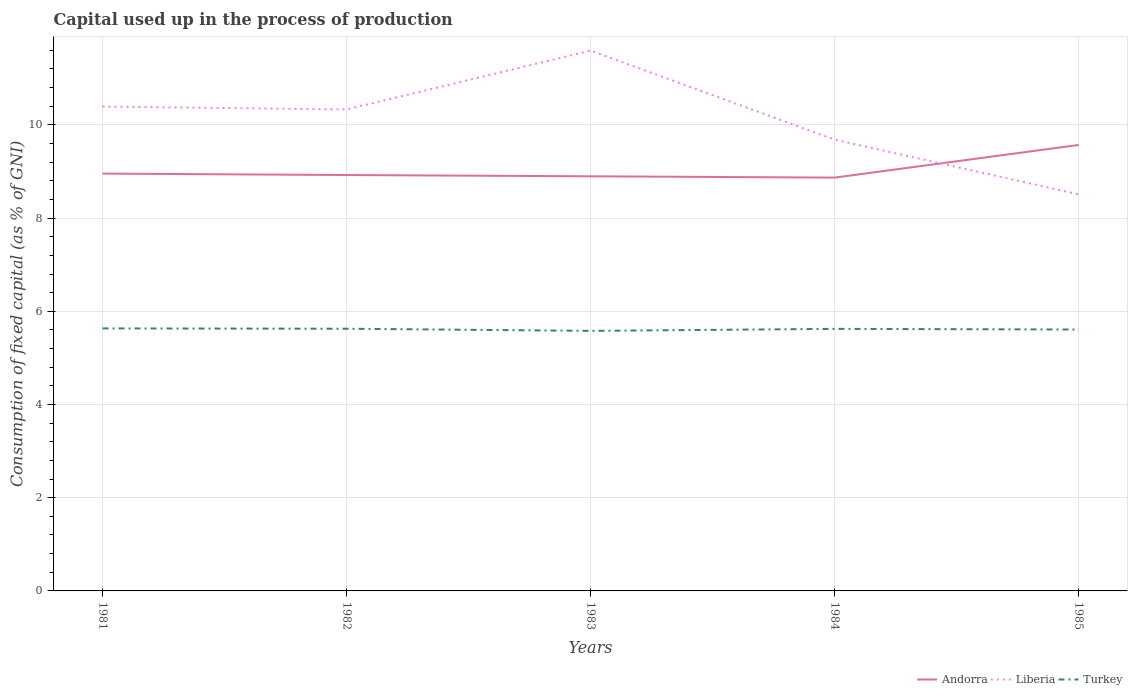How many different coloured lines are there?
Your response must be concise. 3. Does the line corresponding to Liberia intersect with the line corresponding to Turkey?
Make the answer very short. No. Across all years, what is the maximum capital used up in the process of production in Turkey?
Your answer should be compact. 5.58. In which year was the capital used up in the process of production in Andorra maximum?
Give a very brief answer. 1984. What is the total capital used up in the process of production in Turkey in the graph?
Your answer should be compact. 0. What is the difference between the highest and the second highest capital used up in the process of production in Andorra?
Your answer should be compact. 0.7. What is the difference between the highest and the lowest capital used up in the process of production in Liberia?
Provide a succinct answer. 3. Are the values on the major ticks of Y-axis written in scientific E-notation?
Give a very brief answer. No. How are the legend labels stacked?
Offer a very short reply. Horizontal. What is the title of the graph?
Keep it short and to the point. Capital used up in the process of production. What is the label or title of the Y-axis?
Your response must be concise. Consumption of fixed capital (as % of GNI). What is the Consumption of fixed capital (as % of GNI) of Andorra in 1981?
Offer a terse response. 8.95. What is the Consumption of fixed capital (as % of GNI) in Liberia in 1981?
Offer a very short reply. 10.39. What is the Consumption of fixed capital (as % of GNI) in Turkey in 1981?
Offer a very short reply. 5.63. What is the Consumption of fixed capital (as % of GNI) in Andorra in 1982?
Provide a short and direct response. 8.92. What is the Consumption of fixed capital (as % of GNI) of Liberia in 1982?
Your answer should be compact. 10.33. What is the Consumption of fixed capital (as % of GNI) of Turkey in 1982?
Provide a short and direct response. 5.63. What is the Consumption of fixed capital (as % of GNI) of Andorra in 1983?
Make the answer very short. 8.9. What is the Consumption of fixed capital (as % of GNI) of Liberia in 1983?
Provide a short and direct response. 11.59. What is the Consumption of fixed capital (as % of GNI) of Turkey in 1983?
Make the answer very short. 5.58. What is the Consumption of fixed capital (as % of GNI) in Andorra in 1984?
Keep it short and to the point. 8.87. What is the Consumption of fixed capital (as % of GNI) in Liberia in 1984?
Ensure brevity in your answer.  9.68. What is the Consumption of fixed capital (as % of GNI) of Turkey in 1984?
Provide a short and direct response. 5.62. What is the Consumption of fixed capital (as % of GNI) of Andorra in 1985?
Offer a very short reply. 9.57. What is the Consumption of fixed capital (as % of GNI) of Liberia in 1985?
Offer a very short reply. 8.51. What is the Consumption of fixed capital (as % of GNI) in Turkey in 1985?
Offer a terse response. 5.61. Across all years, what is the maximum Consumption of fixed capital (as % of GNI) of Andorra?
Offer a very short reply. 9.57. Across all years, what is the maximum Consumption of fixed capital (as % of GNI) of Liberia?
Provide a succinct answer. 11.59. Across all years, what is the maximum Consumption of fixed capital (as % of GNI) of Turkey?
Keep it short and to the point. 5.63. Across all years, what is the minimum Consumption of fixed capital (as % of GNI) in Andorra?
Offer a terse response. 8.87. Across all years, what is the minimum Consumption of fixed capital (as % of GNI) of Liberia?
Make the answer very short. 8.51. Across all years, what is the minimum Consumption of fixed capital (as % of GNI) in Turkey?
Your answer should be very brief. 5.58. What is the total Consumption of fixed capital (as % of GNI) of Andorra in the graph?
Give a very brief answer. 45.21. What is the total Consumption of fixed capital (as % of GNI) of Liberia in the graph?
Your answer should be very brief. 50.51. What is the total Consumption of fixed capital (as % of GNI) of Turkey in the graph?
Provide a succinct answer. 28.07. What is the difference between the Consumption of fixed capital (as % of GNI) in Andorra in 1981 and that in 1982?
Offer a very short reply. 0.03. What is the difference between the Consumption of fixed capital (as % of GNI) of Liberia in 1981 and that in 1982?
Keep it short and to the point. 0.06. What is the difference between the Consumption of fixed capital (as % of GNI) of Turkey in 1981 and that in 1982?
Keep it short and to the point. 0.01. What is the difference between the Consumption of fixed capital (as % of GNI) in Andorra in 1981 and that in 1983?
Your answer should be compact. 0.06. What is the difference between the Consumption of fixed capital (as % of GNI) in Liberia in 1981 and that in 1983?
Keep it short and to the point. -1.2. What is the difference between the Consumption of fixed capital (as % of GNI) of Turkey in 1981 and that in 1983?
Offer a very short reply. 0.05. What is the difference between the Consumption of fixed capital (as % of GNI) of Andorra in 1981 and that in 1984?
Provide a succinct answer. 0.09. What is the difference between the Consumption of fixed capital (as % of GNI) in Liberia in 1981 and that in 1984?
Ensure brevity in your answer.  0.71. What is the difference between the Consumption of fixed capital (as % of GNI) of Turkey in 1981 and that in 1984?
Offer a very short reply. 0.01. What is the difference between the Consumption of fixed capital (as % of GNI) of Andorra in 1981 and that in 1985?
Ensure brevity in your answer.  -0.61. What is the difference between the Consumption of fixed capital (as % of GNI) of Liberia in 1981 and that in 1985?
Provide a succinct answer. 1.88. What is the difference between the Consumption of fixed capital (as % of GNI) in Turkey in 1981 and that in 1985?
Your answer should be compact. 0.02. What is the difference between the Consumption of fixed capital (as % of GNI) of Andorra in 1982 and that in 1983?
Make the answer very short. 0.03. What is the difference between the Consumption of fixed capital (as % of GNI) in Liberia in 1982 and that in 1983?
Your answer should be very brief. -1.26. What is the difference between the Consumption of fixed capital (as % of GNI) in Turkey in 1982 and that in 1983?
Keep it short and to the point. 0.05. What is the difference between the Consumption of fixed capital (as % of GNI) of Andorra in 1982 and that in 1984?
Provide a succinct answer. 0.06. What is the difference between the Consumption of fixed capital (as % of GNI) in Liberia in 1982 and that in 1984?
Keep it short and to the point. 0.65. What is the difference between the Consumption of fixed capital (as % of GNI) in Turkey in 1982 and that in 1984?
Keep it short and to the point. 0. What is the difference between the Consumption of fixed capital (as % of GNI) of Andorra in 1982 and that in 1985?
Your answer should be compact. -0.65. What is the difference between the Consumption of fixed capital (as % of GNI) of Liberia in 1982 and that in 1985?
Provide a short and direct response. 1.82. What is the difference between the Consumption of fixed capital (as % of GNI) in Turkey in 1982 and that in 1985?
Provide a succinct answer. 0.02. What is the difference between the Consumption of fixed capital (as % of GNI) of Andorra in 1983 and that in 1984?
Provide a succinct answer. 0.03. What is the difference between the Consumption of fixed capital (as % of GNI) of Liberia in 1983 and that in 1984?
Make the answer very short. 1.91. What is the difference between the Consumption of fixed capital (as % of GNI) of Turkey in 1983 and that in 1984?
Keep it short and to the point. -0.04. What is the difference between the Consumption of fixed capital (as % of GNI) of Andorra in 1983 and that in 1985?
Offer a very short reply. -0.67. What is the difference between the Consumption of fixed capital (as % of GNI) in Liberia in 1983 and that in 1985?
Ensure brevity in your answer.  3.08. What is the difference between the Consumption of fixed capital (as % of GNI) of Turkey in 1983 and that in 1985?
Offer a very short reply. -0.03. What is the difference between the Consumption of fixed capital (as % of GNI) in Andorra in 1984 and that in 1985?
Provide a succinct answer. -0.7. What is the difference between the Consumption of fixed capital (as % of GNI) in Liberia in 1984 and that in 1985?
Your answer should be compact. 1.17. What is the difference between the Consumption of fixed capital (as % of GNI) in Turkey in 1984 and that in 1985?
Your answer should be compact. 0.01. What is the difference between the Consumption of fixed capital (as % of GNI) of Andorra in 1981 and the Consumption of fixed capital (as % of GNI) of Liberia in 1982?
Give a very brief answer. -1.38. What is the difference between the Consumption of fixed capital (as % of GNI) of Andorra in 1981 and the Consumption of fixed capital (as % of GNI) of Turkey in 1982?
Provide a succinct answer. 3.33. What is the difference between the Consumption of fixed capital (as % of GNI) in Liberia in 1981 and the Consumption of fixed capital (as % of GNI) in Turkey in 1982?
Make the answer very short. 4.77. What is the difference between the Consumption of fixed capital (as % of GNI) in Andorra in 1981 and the Consumption of fixed capital (as % of GNI) in Liberia in 1983?
Provide a succinct answer. -2.64. What is the difference between the Consumption of fixed capital (as % of GNI) in Andorra in 1981 and the Consumption of fixed capital (as % of GNI) in Turkey in 1983?
Give a very brief answer. 3.37. What is the difference between the Consumption of fixed capital (as % of GNI) of Liberia in 1981 and the Consumption of fixed capital (as % of GNI) of Turkey in 1983?
Provide a short and direct response. 4.81. What is the difference between the Consumption of fixed capital (as % of GNI) of Andorra in 1981 and the Consumption of fixed capital (as % of GNI) of Liberia in 1984?
Offer a very short reply. -0.73. What is the difference between the Consumption of fixed capital (as % of GNI) in Andorra in 1981 and the Consumption of fixed capital (as % of GNI) in Turkey in 1984?
Give a very brief answer. 3.33. What is the difference between the Consumption of fixed capital (as % of GNI) in Liberia in 1981 and the Consumption of fixed capital (as % of GNI) in Turkey in 1984?
Give a very brief answer. 4.77. What is the difference between the Consumption of fixed capital (as % of GNI) in Andorra in 1981 and the Consumption of fixed capital (as % of GNI) in Liberia in 1985?
Give a very brief answer. 0.45. What is the difference between the Consumption of fixed capital (as % of GNI) of Andorra in 1981 and the Consumption of fixed capital (as % of GNI) of Turkey in 1985?
Offer a terse response. 3.35. What is the difference between the Consumption of fixed capital (as % of GNI) in Liberia in 1981 and the Consumption of fixed capital (as % of GNI) in Turkey in 1985?
Make the answer very short. 4.78. What is the difference between the Consumption of fixed capital (as % of GNI) in Andorra in 1982 and the Consumption of fixed capital (as % of GNI) in Liberia in 1983?
Give a very brief answer. -2.67. What is the difference between the Consumption of fixed capital (as % of GNI) in Andorra in 1982 and the Consumption of fixed capital (as % of GNI) in Turkey in 1983?
Ensure brevity in your answer.  3.34. What is the difference between the Consumption of fixed capital (as % of GNI) in Liberia in 1982 and the Consumption of fixed capital (as % of GNI) in Turkey in 1983?
Give a very brief answer. 4.75. What is the difference between the Consumption of fixed capital (as % of GNI) of Andorra in 1982 and the Consumption of fixed capital (as % of GNI) of Liberia in 1984?
Give a very brief answer. -0.76. What is the difference between the Consumption of fixed capital (as % of GNI) of Andorra in 1982 and the Consumption of fixed capital (as % of GNI) of Turkey in 1984?
Make the answer very short. 3.3. What is the difference between the Consumption of fixed capital (as % of GNI) of Liberia in 1982 and the Consumption of fixed capital (as % of GNI) of Turkey in 1984?
Your answer should be very brief. 4.71. What is the difference between the Consumption of fixed capital (as % of GNI) of Andorra in 1982 and the Consumption of fixed capital (as % of GNI) of Liberia in 1985?
Give a very brief answer. 0.41. What is the difference between the Consumption of fixed capital (as % of GNI) in Andorra in 1982 and the Consumption of fixed capital (as % of GNI) in Turkey in 1985?
Your answer should be compact. 3.32. What is the difference between the Consumption of fixed capital (as % of GNI) of Liberia in 1982 and the Consumption of fixed capital (as % of GNI) of Turkey in 1985?
Your response must be concise. 4.72. What is the difference between the Consumption of fixed capital (as % of GNI) in Andorra in 1983 and the Consumption of fixed capital (as % of GNI) in Liberia in 1984?
Keep it short and to the point. -0.79. What is the difference between the Consumption of fixed capital (as % of GNI) of Andorra in 1983 and the Consumption of fixed capital (as % of GNI) of Turkey in 1984?
Your response must be concise. 3.27. What is the difference between the Consumption of fixed capital (as % of GNI) of Liberia in 1983 and the Consumption of fixed capital (as % of GNI) of Turkey in 1984?
Offer a very short reply. 5.97. What is the difference between the Consumption of fixed capital (as % of GNI) in Andorra in 1983 and the Consumption of fixed capital (as % of GNI) in Liberia in 1985?
Your answer should be compact. 0.39. What is the difference between the Consumption of fixed capital (as % of GNI) in Andorra in 1983 and the Consumption of fixed capital (as % of GNI) in Turkey in 1985?
Give a very brief answer. 3.29. What is the difference between the Consumption of fixed capital (as % of GNI) in Liberia in 1983 and the Consumption of fixed capital (as % of GNI) in Turkey in 1985?
Offer a terse response. 5.99. What is the difference between the Consumption of fixed capital (as % of GNI) in Andorra in 1984 and the Consumption of fixed capital (as % of GNI) in Liberia in 1985?
Keep it short and to the point. 0.36. What is the difference between the Consumption of fixed capital (as % of GNI) in Andorra in 1984 and the Consumption of fixed capital (as % of GNI) in Turkey in 1985?
Ensure brevity in your answer.  3.26. What is the difference between the Consumption of fixed capital (as % of GNI) of Liberia in 1984 and the Consumption of fixed capital (as % of GNI) of Turkey in 1985?
Offer a very short reply. 4.07. What is the average Consumption of fixed capital (as % of GNI) of Andorra per year?
Offer a terse response. 9.04. What is the average Consumption of fixed capital (as % of GNI) in Liberia per year?
Make the answer very short. 10.1. What is the average Consumption of fixed capital (as % of GNI) in Turkey per year?
Ensure brevity in your answer.  5.61. In the year 1981, what is the difference between the Consumption of fixed capital (as % of GNI) in Andorra and Consumption of fixed capital (as % of GNI) in Liberia?
Your answer should be compact. -1.44. In the year 1981, what is the difference between the Consumption of fixed capital (as % of GNI) of Andorra and Consumption of fixed capital (as % of GNI) of Turkey?
Your answer should be very brief. 3.32. In the year 1981, what is the difference between the Consumption of fixed capital (as % of GNI) in Liberia and Consumption of fixed capital (as % of GNI) in Turkey?
Give a very brief answer. 4.76. In the year 1982, what is the difference between the Consumption of fixed capital (as % of GNI) in Andorra and Consumption of fixed capital (as % of GNI) in Liberia?
Provide a short and direct response. -1.41. In the year 1982, what is the difference between the Consumption of fixed capital (as % of GNI) in Andorra and Consumption of fixed capital (as % of GNI) in Turkey?
Keep it short and to the point. 3.3. In the year 1982, what is the difference between the Consumption of fixed capital (as % of GNI) in Liberia and Consumption of fixed capital (as % of GNI) in Turkey?
Your response must be concise. 4.7. In the year 1983, what is the difference between the Consumption of fixed capital (as % of GNI) of Andorra and Consumption of fixed capital (as % of GNI) of Liberia?
Provide a short and direct response. -2.7. In the year 1983, what is the difference between the Consumption of fixed capital (as % of GNI) in Andorra and Consumption of fixed capital (as % of GNI) in Turkey?
Make the answer very short. 3.32. In the year 1983, what is the difference between the Consumption of fixed capital (as % of GNI) of Liberia and Consumption of fixed capital (as % of GNI) of Turkey?
Your answer should be compact. 6.01. In the year 1984, what is the difference between the Consumption of fixed capital (as % of GNI) of Andorra and Consumption of fixed capital (as % of GNI) of Liberia?
Offer a terse response. -0.81. In the year 1984, what is the difference between the Consumption of fixed capital (as % of GNI) in Andorra and Consumption of fixed capital (as % of GNI) in Turkey?
Offer a terse response. 3.25. In the year 1984, what is the difference between the Consumption of fixed capital (as % of GNI) in Liberia and Consumption of fixed capital (as % of GNI) in Turkey?
Your response must be concise. 4.06. In the year 1985, what is the difference between the Consumption of fixed capital (as % of GNI) of Andorra and Consumption of fixed capital (as % of GNI) of Liberia?
Ensure brevity in your answer.  1.06. In the year 1985, what is the difference between the Consumption of fixed capital (as % of GNI) of Andorra and Consumption of fixed capital (as % of GNI) of Turkey?
Offer a terse response. 3.96. In the year 1985, what is the difference between the Consumption of fixed capital (as % of GNI) of Liberia and Consumption of fixed capital (as % of GNI) of Turkey?
Provide a succinct answer. 2.9. What is the ratio of the Consumption of fixed capital (as % of GNI) in Andorra in 1981 to that in 1982?
Ensure brevity in your answer.  1. What is the ratio of the Consumption of fixed capital (as % of GNI) of Turkey in 1981 to that in 1982?
Provide a succinct answer. 1. What is the ratio of the Consumption of fixed capital (as % of GNI) in Andorra in 1981 to that in 1983?
Your answer should be very brief. 1.01. What is the ratio of the Consumption of fixed capital (as % of GNI) of Liberia in 1981 to that in 1983?
Provide a succinct answer. 0.9. What is the ratio of the Consumption of fixed capital (as % of GNI) of Turkey in 1981 to that in 1983?
Offer a very short reply. 1.01. What is the ratio of the Consumption of fixed capital (as % of GNI) in Andorra in 1981 to that in 1984?
Give a very brief answer. 1.01. What is the ratio of the Consumption of fixed capital (as % of GNI) of Liberia in 1981 to that in 1984?
Offer a terse response. 1.07. What is the ratio of the Consumption of fixed capital (as % of GNI) in Andorra in 1981 to that in 1985?
Offer a very short reply. 0.94. What is the ratio of the Consumption of fixed capital (as % of GNI) in Liberia in 1981 to that in 1985?
Provide a short and direct response. 1.22. What is the ratio of the Consumption of fixed capital (as % of GNI) of Andorra in 1982 to that in 1983?
Offer a terse response. 1. What is the ratio of the Consumption of fixed capital (as % of GNI) in Liberia in 1982 to that in 1983?
Your answer should be compact. 0.89. What is the ratio of the Consumption of fixed capital (as % of GNI) of Turkey in 1982 to that in 1983?
Keep it short and to the point. 1.01. What is the ratio of the Consumption of fixed capital (as % of GNI) in Andorra in 1982 to that in 1984?
Offer a very short reply. 1.01. What is the ratio of the Consumption of fixed capital (as % of GNI) of Liberia in 1982 to that in 1984?
Give a very brief answer. 1.07. What is the ratio of the Consumption of fixed capital (as % of GNI) in Andorra in 1982 to that in 1985?
Ensure brevity in your answer.  0.93. What is the ratio of the Consumption of fixed capital (as % of GNI) in Liberia in 1982 to that in 1985?
Make the answer very short. 1.21. What is the ratio of the Consumption of fixed capital (as % of GNI) in Turkey in 1982 to that in 1985?
Offer a very short reply. 1. What is the ratio of the Consumption of fixed capital (as % of GNI) in Andorra in 1983 to that in 1984?
Your response must be concise. 1. What is the ratio of the Consumption of fixed capital (as % of GNI) in Liberia in 1983 to that in 1984?
Provide a succinct answer. 1.2. What is the ratio of the Consumption of fixed capital (as % of GNI) in Andorra in 1983 to that in 1985?
Keep it short and to the point. 0.93. What is the ratio of the Consumption of fixed capital (as % of GNI) of Liberia in 1983 to that in 1985?
Your answer should be compact. 1.36. What is the ratio of the Consumption of fixed capital (as % of GNI) of Turkey in 1983 to that in 1985?
Provide a short and direct response. 0.99. What is the ratio of the Consumption of fixed capital (as % of GNI) of Andorra in 1984 to that in 1985?
Provide a short and direct response. 0.93. What is the ratio of the Consumption of fixed capital (as % of GNI) of Liberia in 1984 to that in 1985?
Your answer should be compact. 1.14. What is the ratio of the Consumption of fixed capital (as % of GNI) of Turkey in 1984 to that in 1985?
Make the answer very short. 1. What is the difference between the highest and the second highest Consumption of fixed capital (as % of GNI) in Andorra?
Your answer should be very brief. 0.61. What is the difference between the highest and the second highest Consumption of fixed capital (as % of GNI) of Liberia?
Give a very brief answer. 1.2. What is the difference between the highest and the second highest Consumption of fixed capital (as % of GNI) of Turkey?
Offer a terse response. 0.01. What is the difference between the highest and the lowest Consumption of fixed capital (as % of GNI) of Andorra?
Your answer should be compact. 0.7. What is the difference between the highest and the lowest Consumption of fixed capital (as % of GNI) in Liberia?
Give a very brief answer. 3.08. What is the difference between the highest and the lowest Consumption of fixed capital (as % of GNI) in Turkey?
Keep it short and to the point. 0.05. 